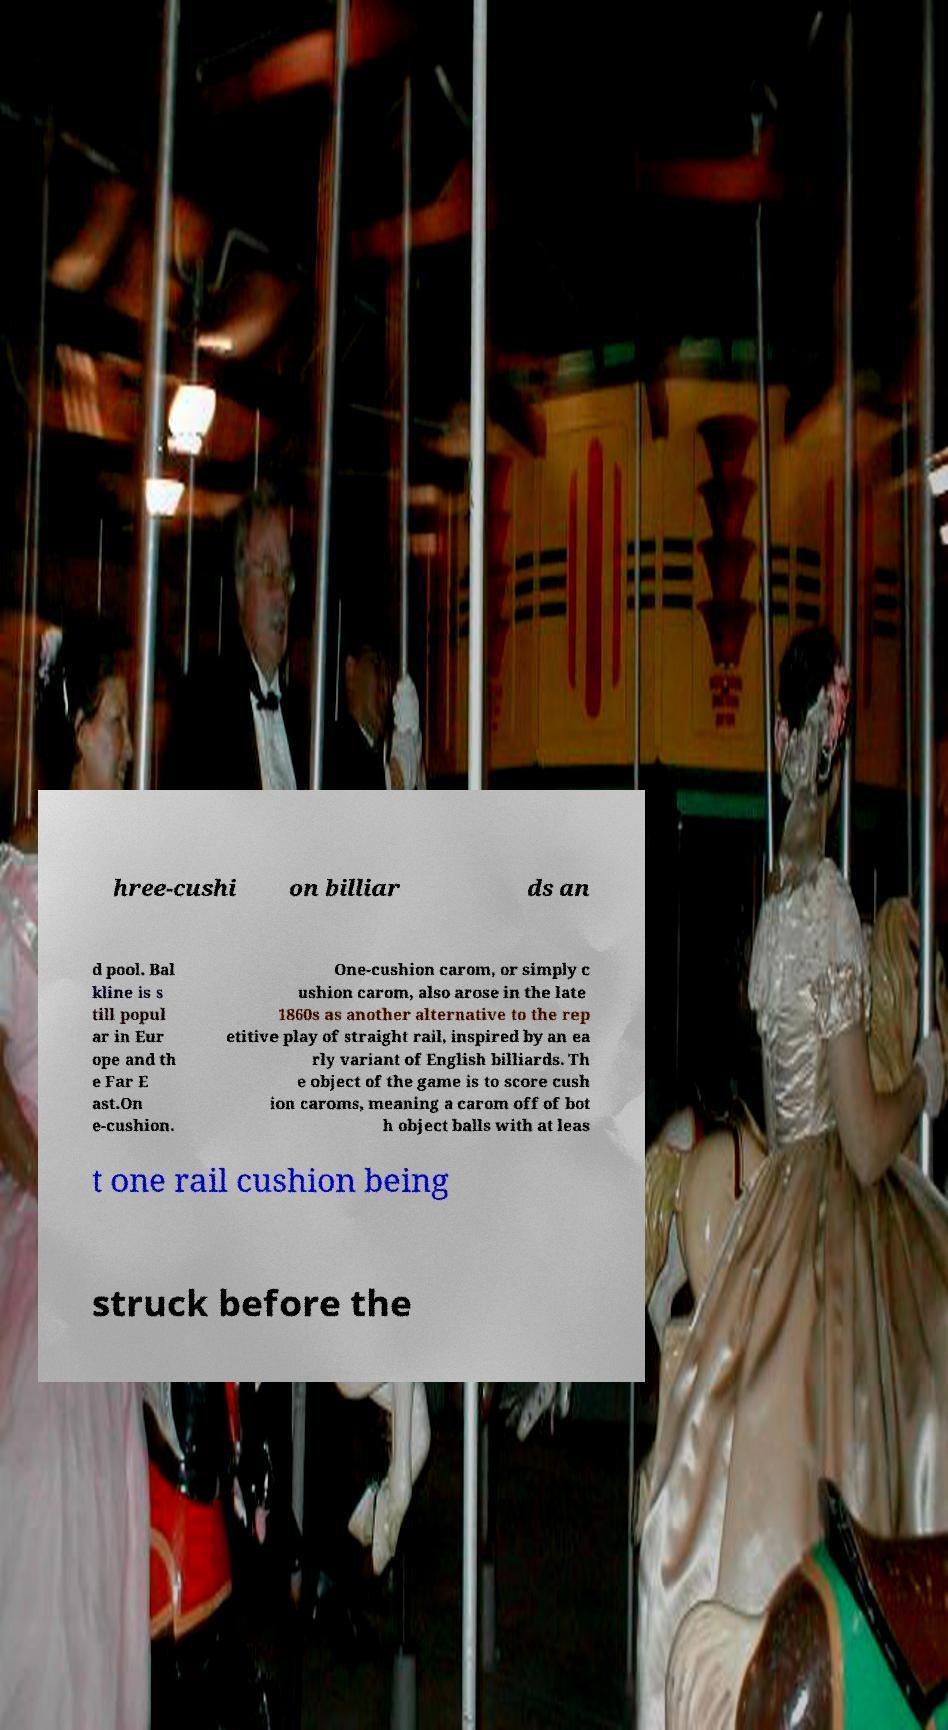Please identify and transcribe the text found in this image. hree-cushi on billiar ds an d pool. Bal kline is s till popul ar in Eur ope and th e Far E ast.On e-cushion. One-cushion carom, or simply c ushion carom, also arose in the late 1860s as another alternative to the rep etitive play of straight rail, inspired by an ea rly variant of English billiards. Th e object of the game is to score cush ion caroms, meaning a carom off of bot h object balls with at leas t one rail cushion being struck before the 